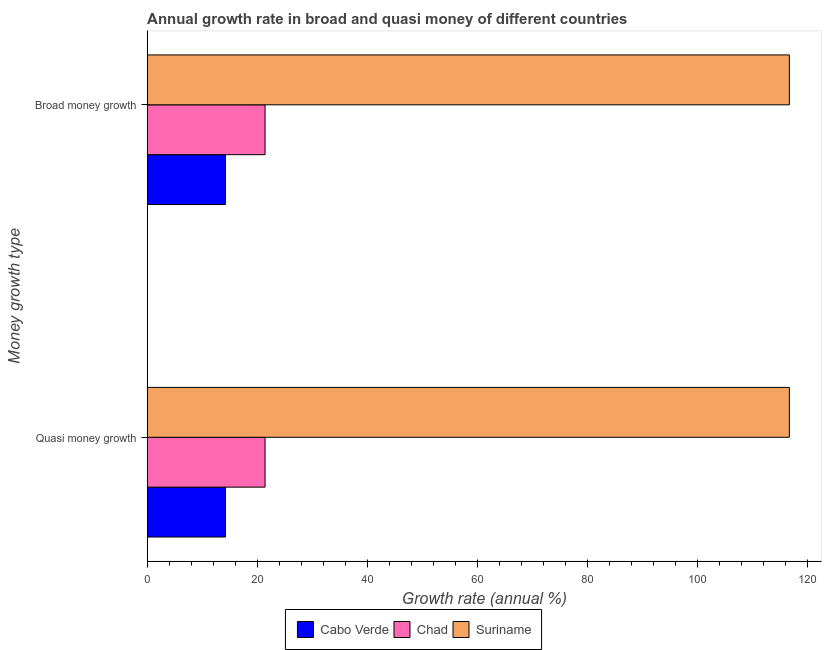How many different coloured bars are there?
Provide a succinct answer. 3. How many groups of bars are there?
Provide a short and direct response. 2. Are the number of bars per tick equal to the number of legend labels?
Offer a very short reply. Yes. How many bars are there on the 2nd tick from the bottom?
Your response must be concise. 3. What is the label of the 1st group of bars from the top?
Make the answer very short. Broad money growth. What is the annual growth rate in broad money in Cabo Verde?
Make the answer very short. 14.22. Across all countries, what is the maximum annual growth rate in broad money?
Offer a very short reply. 116.75. Across all countries, what is the minimum annual growth rate in broad money?
Keep it short and to the point. 14.22. In which country was the annual growth rate in broad money maximum?
Provide a short and direct response. Suriname. In which country was the annual growth rate in broad money minimum?
Give a very brief answer. Cabo Verde. What is the total annual growth rate in broad money in the graph?
Make the answer very short. 152.4. What is the difference between the annual growth rate in broad money in Cabo Verde and that in Suriname?
Your answer should be compact. -102.53. What is the difference between the annual growth rate in quasi money in Suriname and the annual growth rate in broad money in Cabo Verde?
Make the answer very short. 102.53. What is the average annual growth rate in broad money per country?
Keep it short and to the point. 50.8. What is the difference between the annual growth rate in broad money and annual growth rate in quasi money in Chad?
Your answer should be very brief. 0. In how many countries, is the annual growth rate in quasi money greater than 4 %?
Your response must be concise. 3. What is the ratio of the annual growth rate in quasi money in Chad to that in Cabo Verde?
Give a very brief answer. 1.51. What does the 1st bar from the top in Broad money growth represents?
Provide a short and direct response. Suriname. What does the 3rd bar from the bottom in Quasi money growth represents?
Your response must be concise. Suriname. How many bars are there?
Offer a terse response. 6. How many countries are there in the graph?
Your answer should be very brief. 3. What is the difference between two consecutive major ticks on the X-axis?
Ensure brevity in your answer.  20. Are the values on the major ticks of X-axis written in scientific E-notation?
Offer a very short reply. No. How many legend labels are there?
Offer a very short reply. 3. What is the title of the graph?
Your response must be concise. Annual growth rate in broad and quasi money of different countries. What is the label or title of the X-axis?
Make the answer very short. Growth rate (annual %). What is the label or title of the Y-axis?
Keep it short and to the point. Money growth type. What is the Growth rate (annual %) in Cabo Verde in Quasi money growth?
Give a very brief answer. 14.22. What is the Growth rate (annual %) in Chad in Quasi money growth?
Your answer should be very brief. 21.43. What is the Growth rate (annual %) of Suriname in Quasi money growth?
Offer a terse response. 116.75. What is the Growth rate (annual %) of Cabo Verde in Broad money growth?
Offer a very short reply. 14.22. What is the Growth rate (annual %) in Chad in Broad money growth?
Your answer should be compact. 21.43. What is the Growth rate (annual %) in Suriname in Broad money growth?
Make the answer very short. 116.75. Across all Money growth type, what is the maximum Growth rate (annual %) of Cabo Verde?
Give a very brief answer. 14.22. Across all Money growth type, what is the maximum Growth rate (annual %) in Chad?
Your answer should be very brief. 21.43. Across all Money growth type, what is the maximum Growth rate (annual %) of Suriname?
Your answer should be very brief. 116.75. Across all Money growth type, what is the minimum Growth rate (annual %) in Cabo Verde?
Ensure brevity in your answer.  14.22. Across all Money growth type, what is the minimum Growth rate (annual %) in Chad?
Provide a succinct answer. 21.43. Across all Money growth type, what is the minimum Growth rate (annual %) in Suriname?
Offer a terse response. 116.75. What is the total Growth rate (annual %) in Cabo Verde in the graph?
Provide a succinct answer. 28.44. What is the total Growth rate (annual %) of Chad in the graph?
Make the answer very short. 42.86. What is the total Growth rate (annual %) in Suriname in the graph?
Offer a very short reply. 233.5. What is the difference between the Growth rate (annual %) in Cabo Verde in Quasi money growth and that in Broad money growth?
Keep it short and to the point. 0. What is the difference between the Growth rate (annual %) of Suriname in Quasi money growth and that in Broad money growth?
Provide a succinct answer. 0. What is the difference between the Growth rate (annual %) in Cabo Verde in Quasi money growth and the Growth rate (annual %) in Chad in Broad money growth?
Offer a terse response. -7.21. What is the difference between the Growth rate (annual %) of Cabo Verde in Quasi money growth and the Growth rate (annual %) of Suriname in Broad money growth?
Give a very brief answer. -102.53. What is the difference between the Growth rate (annual %) of Chad in Quasi money growth and the Growth rate (annual %) of Suriname in Broad money growth?
Keep it short and to the point. -95.32. What is the average Growth rate (annual %) in Cabo Verde per Money growth type?
Provide a short and direct response. 14.22. What is the average Growth rate (annual %) of Chad per Money growth type?
Provide a short and direct response. 21.43. What is the average Growth rate (annual %) of Suriname per Money growth type?
Keep it short and to the point. 116.75. What is the difference between the Growth rate (annual %) of Cabo Verde and Growth rate (annual %) of Chad in Quasi money growth?
Provide a short and direct response. -7.21. What is the difference between the Growth rate (annual %) of Cabo Verde and Growth rate (annual %) of Suriname in Quasi money growth?
Provide a short and direct response. -102.53. What is the difference between the Growth rate (annual %) in Chad and Growth rate (annual %) in Suriname in Quasi money growth?
Ensure brevity in your answer.  -95.32. What is the difference between the Growth rate (annual %) of Cabo Verde and Growth rate (annual %) of Chad in Broad money growth?
Offer a terse response. -7.21. What is the difference between the Growth rate (annual %) in Cabo Verde and Growth rate (annual %) in Suriname in Broad money growth?
Provide a succinct answer. -102.53. What is the difference between the Growth rate (annual %) of Chad and Growth rate (annual %) of Suriname in Broad money growth?
Provide a succinct answer. -95.32. What is the difference between the highest and the second highest Growth rate (annual %) of Suriname?
Your response must be concise. 0. What is the difference between the highest and the lowest Growth rate (annual %) in Cabo Verde?
Your answer should be compact. 0. What is the difference between the highest and the lowest Growth rate (annual %) in Chad?
Offer a terse response. 0. 